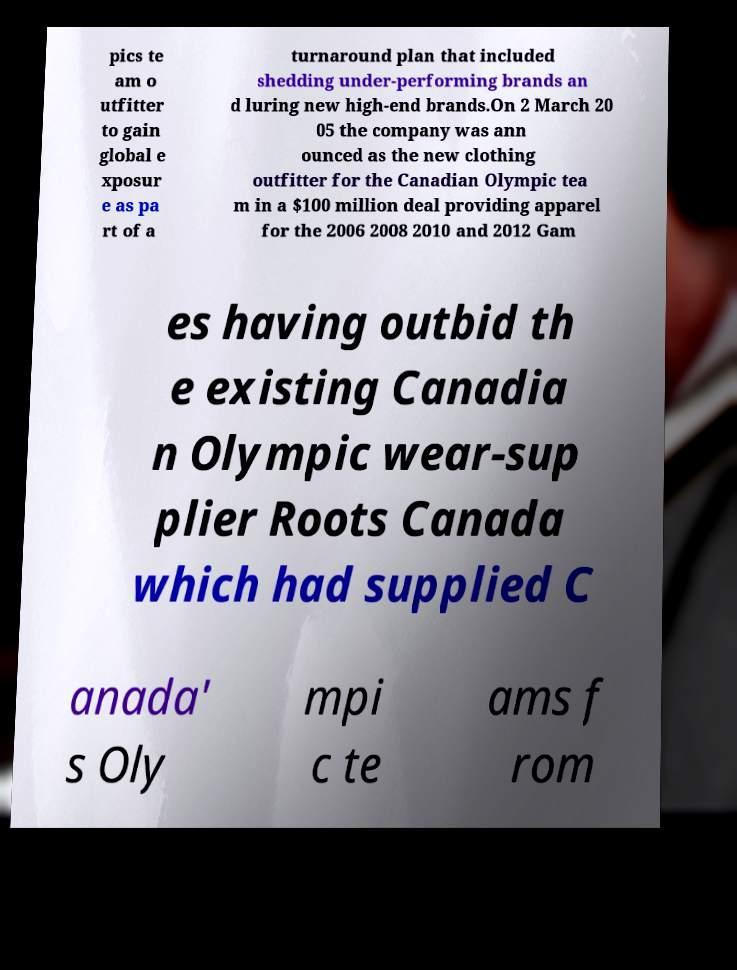Can you accurately transcribe the text from the provided image for me? pics te am o utfitter to gain global e xposur e as pa rt of a turnaround plan that included shedding under-performing brands an d luring new high-end brands.On 2 March 20 05 the company was ann ounced as the new clothing outfitter for the Canadian Olympic tea m in a $100 million deal providing apparel for the 2006 2008 2010 and 2012 Gam es having outbid th e existing Canadia n Olympic wear-sup plier Roots Canada which had supplied C anada' s Oly mpi c te ams f rom 